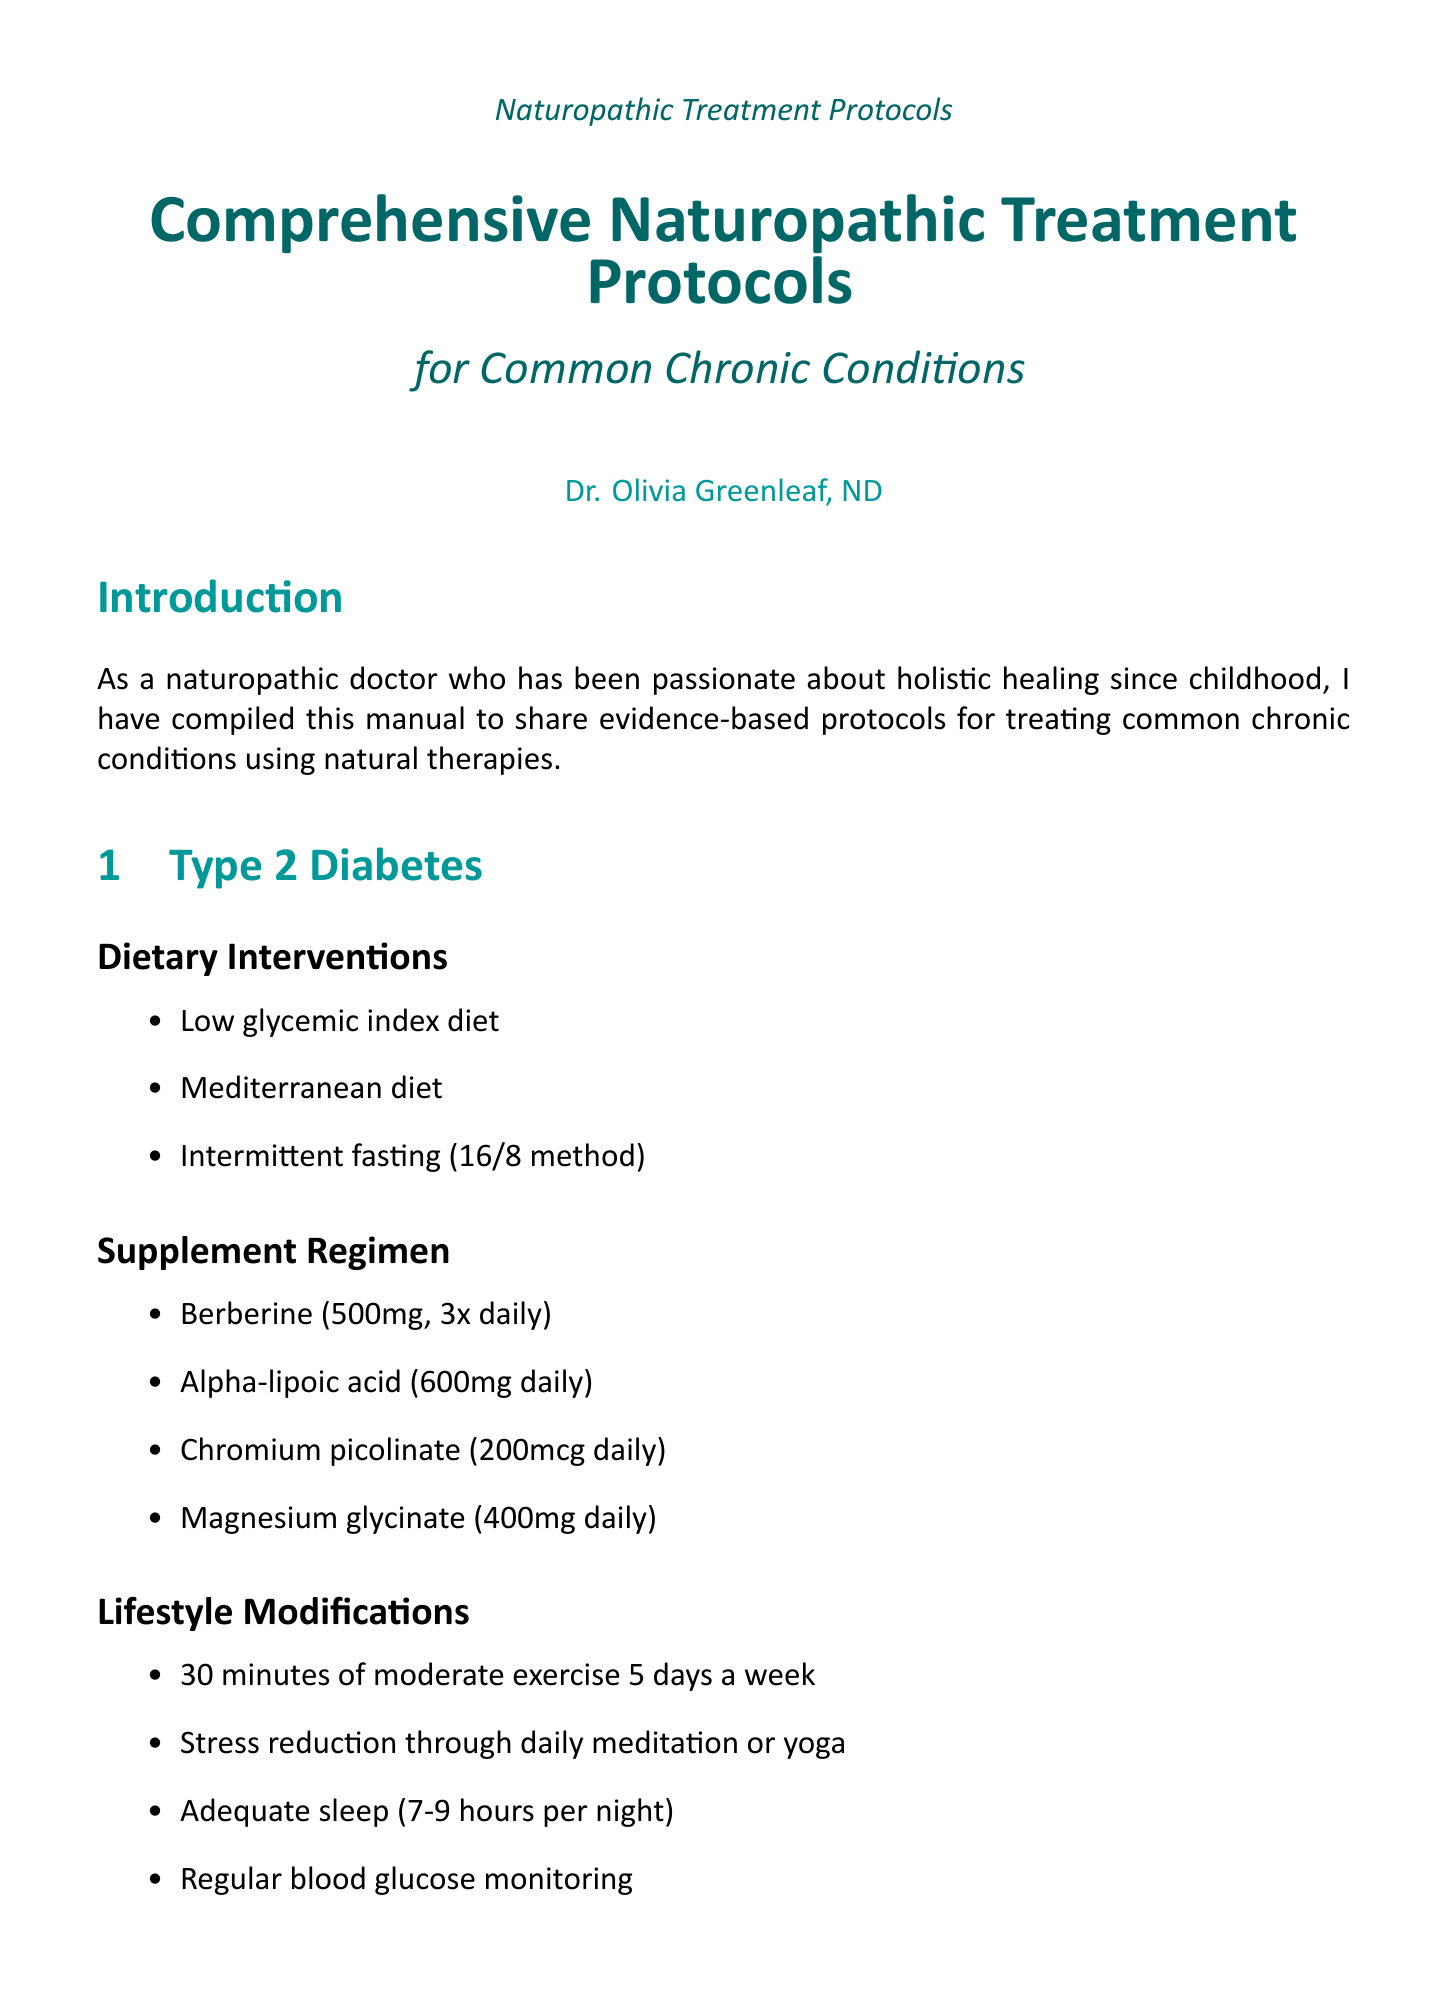What is the title of the manual? The title of the manual is provided at the beginning of the document.
Answer: Comprehensive Naturopathic Treatment Protocols for Common Chronic Conditions Who is the author of the manual? The author is mentioned in the document, specifically in the author's section.
Answer: Dr. Olivia Greenleaf, ND What is one dietary intervention for Type 2 Diabetes? The manual lists specific dietary interventions for Type 2 Diabetes.
Answer: Low glycemic index diet How many times a week should moderate exercise be done for Type 2 Diabetes? The lifestyle modifications section for Type 2 Diabetes provides a specific frequency for exercise.
Answer: 5 days a week Which supplement has a recommended dosage of 10mg daily for Chronic Fatigue Syndrome? The supplement regimens specify dosages for each condition, including Chronic Fatigue Syndrome.
Answer: NADH What type of therapy is recommended weekly for Rheumatoid Arthritis? The lifestyle modifications for Rheumatoid Arthritis include different therapies.
Answer: Acupuncture Name one food group recommended for Hypothyroidism. The dietary interventions for Hypothyroidism list specific food groups.
Answer: Iodine-rich foods How often should infrared sauna sessions be done for hypothyroidism? The lifestyle modifications section for hypothyroidism includes a frequency for sauna sessions.
Answer: 2-3 times per week What is the target audience for this manual? The introduction mentions the purpose and audience of the manual focused on healthcare practitioners.
Answer: Naturopathic doctors and patients 